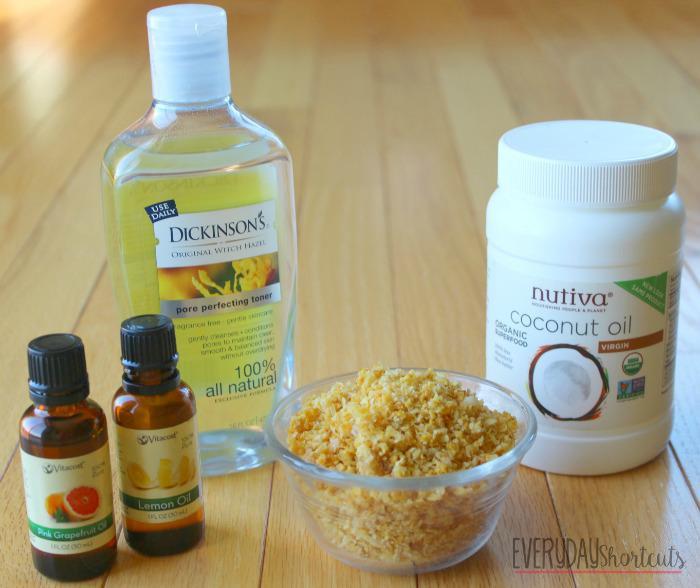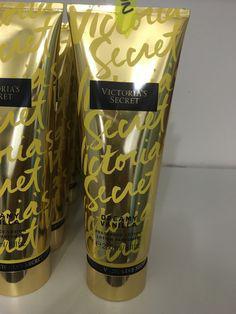The first image is the image on the left, the second image is the image on the right. Assess this claim about the two images: "A pump bottle of lotion is in one image with two other labeled products, while the second image shows an open jar of body cream among other items.". Correct or not? Answer yes or no. No. The first image is the image on the left, the second image is the image on the right. For the images displayed, is the sentence "An image includes an unlidded glass jar containing a pale creamy substance." factually correct? Answer yes or no. No. 